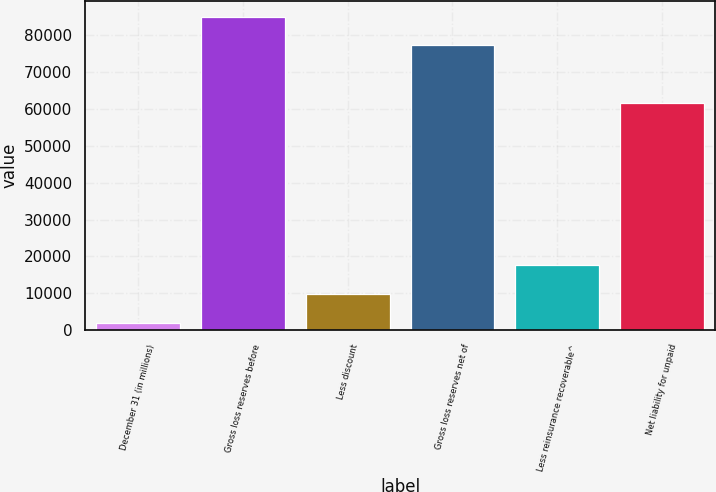Convert chart to OTSL. <chart><loc_0><loc_0><loc_500><loc_500><bar_chart><fcel>December 31 (in millions)<fcel>Gross loss reserves before<fcel>Less discount<fcel>Gross loss reserves net of<fcel>Less reinsurance recoverable^<fcel>Net liability for unpaid<nl><fcel>2014<fcel>85092.3<fcel>9846.3<fcel>77260<fcel>17678.6<fcel>61612<nl></chart> 